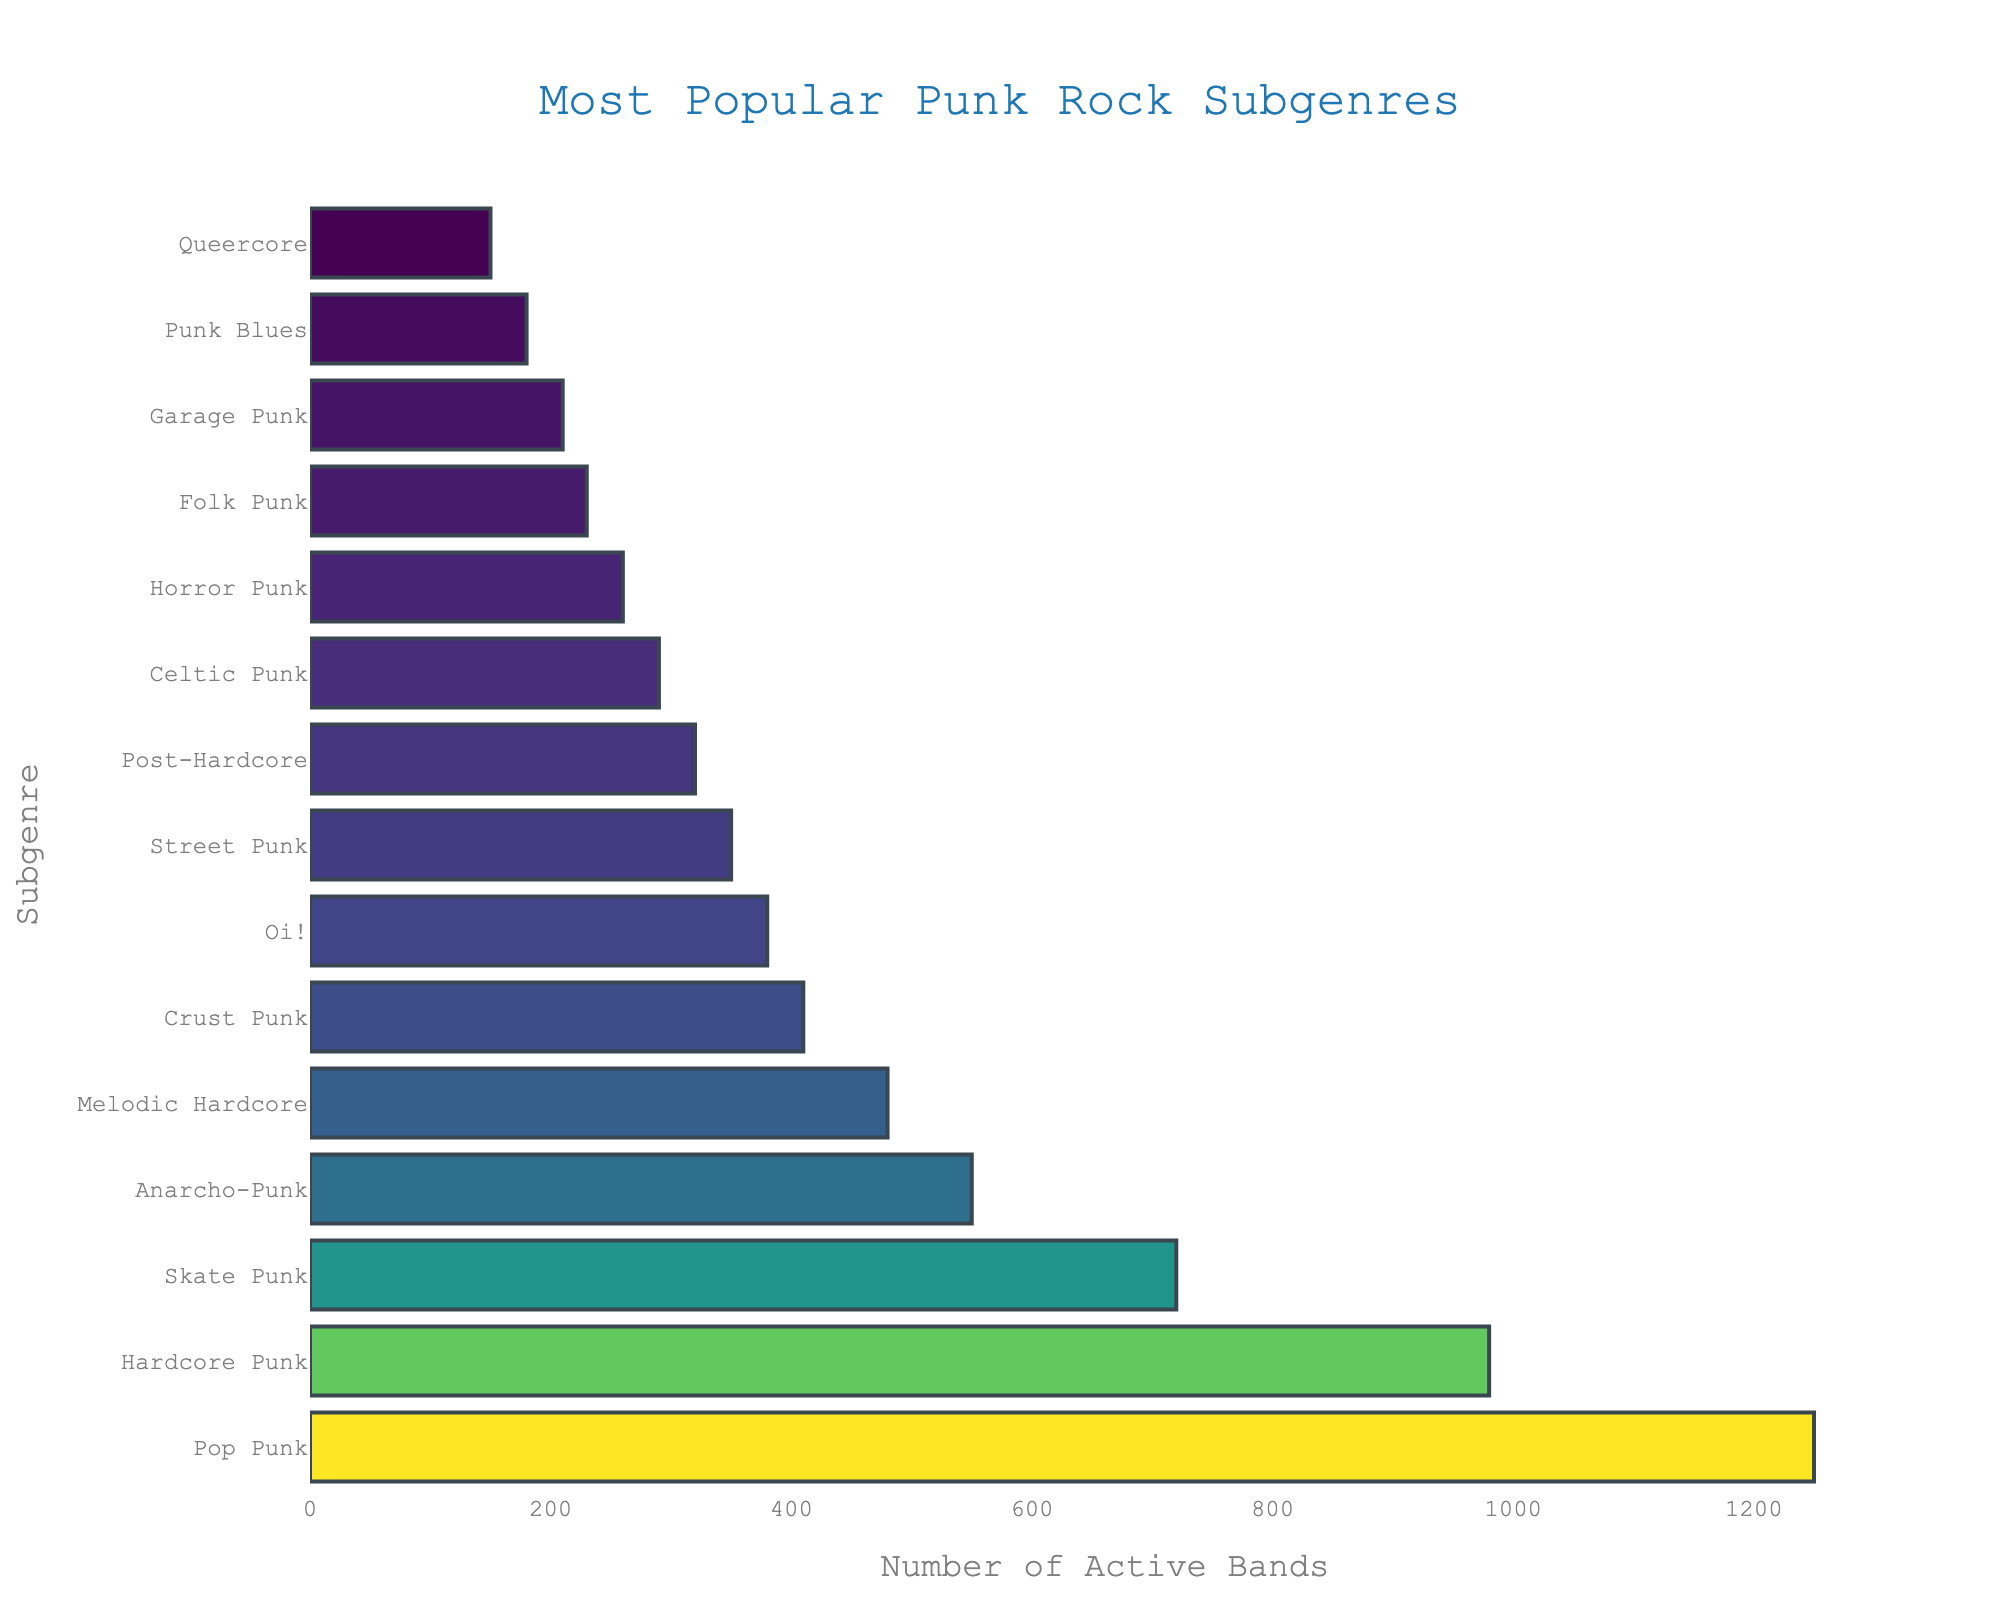How many more active bands are there in Pop Punk compared to Hardcore Punk? To find the difference in the number of active bands between Pop Punk and Hardcore Punk, subtract the number of active bands in Hardcore Punk from the number in Pop Punk. The calculation is 1250 (Pop Punk) - 980 (Hardcore Punk).
Answer: 270 Which subgenre has fewer active bands, Anarcho-Punk or Melodic Hardcore? To determine which subgenre has fewer active bands, compare the number of active bands for Anarcho-Punk and Melodic Hardcore. Anarcho-Punk has 550 bands, and Melodic Hardcore has 480 bands.
Answer: Melodic Hardcore What is the total number of active bands in the five least popular subgenres? To find the total, sum the number of active bands in the five least popular subgenres: Queercore (150), Punk Blues (180), Garage Punk (210), Folk Punk (230), and Horror Punk (260). The calculation is 150 + 180 + 210 + 230 + 260.
Answer: 1030 Which subgenre has the third highest number of active bands? Identify the third highest value in the sorted list of active bands. Pop Punk is first (1250), Hardcore Punk is second (980), and Skate Punk is third (720).
Answer: Skate Punk What is the sum of active bands in Oi! and Street Punk combined? To find the sum, add the number of active bands in Oi! and Street Punk: 380 (Oi!) + 350 (Street Punk). The calculation is 380 + 350.
Answer: 730 Which subgenre has a higher number of active bands, Celtic Punk or Post-Hardcore? Compare the number of active bands for Celtic Punk and Post-Hardcore. Celtic Punk has 290 bands, and Post-Hardcore has 320 bands.
Answer: Post-Hardcore How many active bands are there in subgenres with more than 500 bands? Identify subgenres with more than 500 active bands and sum their numbers: Pop Punk (1250), Hardcore Punk (980), Anarcho-Punk (550). The calculation is 1250 + 980 + 550.
Answer: 2780 What is the average number of active bands in the subgenres that have more than 400 but fewer than 800 bands? Identify the subgenres: Skate Punk (720), Anarcho-Punk (550), and Melodic Hardcore (480). Calculate the average by summing their numbers and dividing by the count. The calculation is (720 + 550 + 480) / 3.
Answer: 583.33 What is the color of the bar representing Street Punk? Describe the color of the bar based on the provided colorscale. Given the Viridis colorscale used and the position of Street Punk’s bar, it would likely be green-ish.
Answer: Greenish 